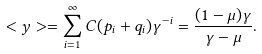<formula> <loc_0><loc_0><loc_500><loc_500>< y > = \sum _ { i = 1 } ^ { \infty } C ( p _ { i } + q _ { i } ) \gamma ^ { - i } = \frac { ( 1 - \mu ) \gamma } { \gamma - \mu } .</formula> 